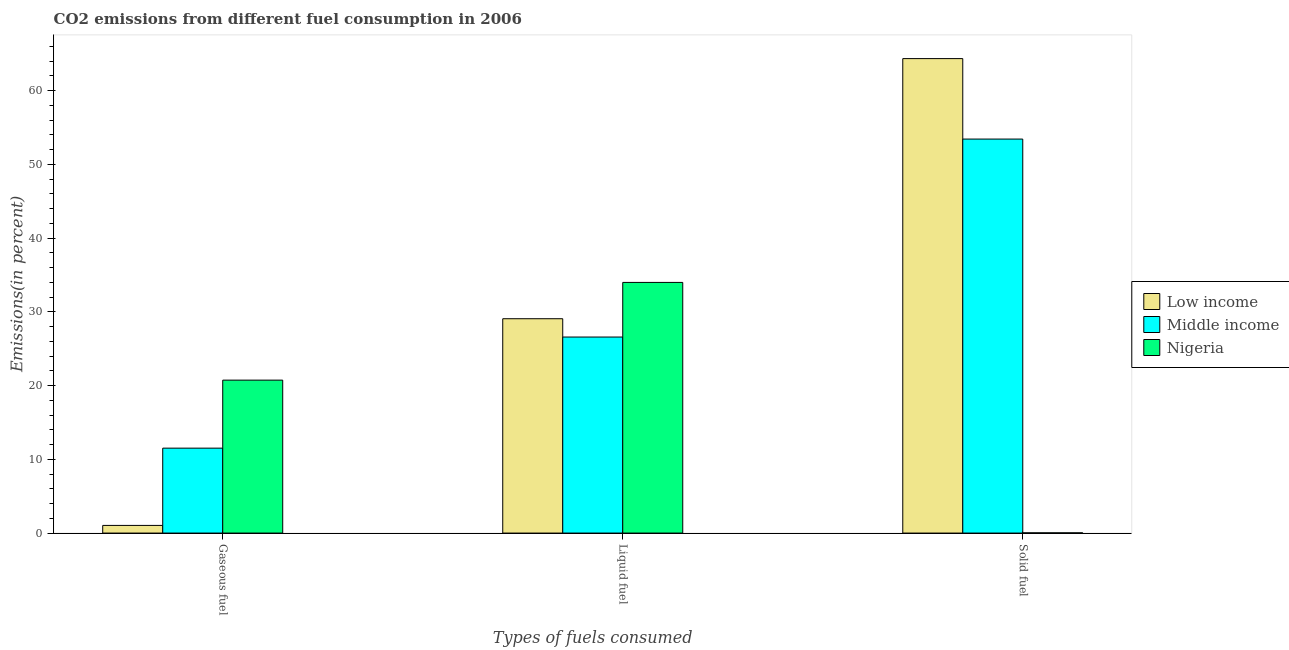How many different coloured bars are there?
Keep it short and to the point. 3. What is the label of the 3rd group of bars from the left?
Offer a terse response. Solid fuel. What is the percentage of solid fuel emission in Middle income?
Keep it short and to the point. 53.42. Across all countries, what is the maximum percentage of gaseous fuel emission?
Your answer should be compact. 20.74. Across all countries, what is the minimum percentage of solid fuel emission?
Keep it short and to the point. 0.03. In which country was the percentage of gaseous fuel emission maximum?
Your answer should be compact. Nigeria. In which country was the percentage of solid fuel emission minimum?
Ensure brevity in your answer.  Nigeria. What is the total percentage of gaseous fuel emission in the graph?
Provide a succinct answer. 33.29. What is the difference between the percentage of gaseous fuel emission in Middle income and that in Nigeria?
Keep it short and to the point. -9.22. What is the difference between the percentage of liquid fuel emission in Low income and the percentage of gaseous fuel emission in Nigeria?
Your answer should be compact. 8.33. What is the average percentage of gaseous fuel emission per country?
Your answer should be compact. 11.1. What is the difference between the percentage of liquid fuel emission and percentage of gaseous fuel emission in Middle income?
Keep it short and to the point. 15.06. What is the ratio of the percentage of solid fuel emission in Middle income to that in Low income?
Offer a very short reply. 0.83. What is the difference between the highest and the second highest percentage of liquid fuel emission?
Make the answer very short. 4.92. What is the difference between the highest and the lowest percentage of gaseous fuel emission?
Provide a short and direct response. 19.7. What does the 3rd bar from the left in Solid fuel represents?
Your answer should be very brief. Nigeria. What does the 1st bar from the right in Liquid fuel represents?
Give a very brief answer. Nigeria. Is it the case that in every country, the sum of the percentage of gaseous fuel emission and percentage of liquid fuel emission is greater than the percentage of solid fuel emission?
Make the answer very short. No. How many bars are there?
Give a very brief answer. 9. Are all the bars in the graph horizontal?
Your answer should be very brief. No. Are the values on the major ticks of Y-axis written in scientific E-notation?
Offer a very short reply. No. Does the graph contain grids?
Provide a short and direct response. No. How many legend labels are there?
Ensure brevity in your answer.  3. How are the legend labels stacked?
Keep it short and to the point. Vertical. What is the title of the graph?
Offer a very short reply. CO2 emissions from different fuel consumption in 2006. What is the label or title of the X-axis?
Keep it short and to the point. Types of fuels consumed. What is the label or title of the Y-axis?
Make the answer very short. Emissions(in percent). What is the Emissions(in percent) of Low income in Gaseous fuel?
Keep it short and to the point. 1.04. What is the Emissions(in percent) in Middle income in Gaseous fuel?
Your response must be concise. 11.52. What is the Emissions(in percent) in Nigeria in Gaseous fuel?
Ensure brevity in your answer.  20.74. What is the Emissions(in percent) of Low income in Liquid fuel?
Your answer should be compact. 29.06. What is the Emissions(in percent) of Middle income in Liquid fuel?
Your answer should be very brief. 26.58. What is the Emissions(in percent) of Nigeria in Liquid fuel?
Ensure brevity in your answer.  33.98. What is the Emissions(in percent) of Low income in Solid fuel?
Provide a succinct answer. 64.33. What is the Emissions(in percent) in Middle income in Solid fuel?
Make the answer very short. 53.42. What is the Emissions(in percent) of Nigeria in Solid fuel?
Offer a terse response. 0.03. Across all Types of fuels consumed, what is the maximum Emissions(in percent) of Low income?
Give a very brief answer. 64.33. Across all Types of fuels consumed, what is the maximum Emissions(in percent) in Middle income?
Your answer should be compact. 53.42. Across all Types of fuels consumed, what is the maximum Emissions(in percent) of Nigeria?
Your answer should be compact. 33.98. Across all Types of fuels consumed, what is the minimum Emissions(in percent) in Low income?
Your response must be concise. 1.04. Across all Types of fuels consumed, what is the minimum Emissions(in percent) in Middle income?
Keep it short and to the point. 11.52. Across all Types of fuels consumed, what is the minimum Emissions(in percent) in Nigeria?
Give a very brief answer. 0.03. What is the total Emissions(in percent) in Low income in the graph?
Offer a very short reply. 94.43. What is the total Emissions(in percent) in Middle income in the graph?
Give a very brief answer. 91.51. What is the total Emissions(in percent) in Nigeria in the graph?
Provide a succinct answer. 54.75. What is the difference between the Emissions(in percent) of Low income in Gaseous fuel and that in Liquid fuel?
Offer a terse response. -28.02. What is the difference between the Emissions(in percent) of Middle income in Gaseous fuel and that in Liquid fuel?
Make the answer very short. -15.06. What is the difference between the Emissions(in percent) in Nigeria in Gaseous fuel and that in Liquid fuel?
Ensure brevity in your answer.  -13.25. What is the difference between the Emissions(in percent) in Low income in Gaseous fuel and that in Solid fuel?
Your answer should be very brief. -63.29. What is the difference between the Emissions(in percent) of Middle income in Gaseous fuel and that in Solid fuel?
Your answer should be very brief. -41.9. What is the difference between the Emissions(in percent) of Nigeria in Gaseous fuel and that in Solid fuel?
Your answer should be compact. 20.71. What is the difference between the Emissions(in percent) in Low income in Liquid fuel and that in Solid fuel?
Your answer should be very brief. -35.27. What is the difference between the Emissions(in percent) of Middle income in Liquid fuel and that in Solid fuel?
Offer a very short reply. -26.84. What is the difference between the Emissions(in percent) of Nigeria in Liquid fuel and that in Solid fuel?
Provide a succinct answer. 33.95. What is the difference between the Emissions(in percent) in Low income in Gaseous fuel and the Emissions(in percent) in Middle income in Liquid fuel?
Ensure brevity in your answer.  -25.54. What is the difference between the Emissions(in percent) in Low income in Gaseous fuel and the Emissions(in percent) in Nigeria in Liquid fuel?
Give a very brief answer. -32.95. What is the difference between the Emissions(in percent) of Middle income in Gaseous fuel and the Emissions(in percent) of Nigeria in Liquid fuel?
Provide a succinct answer. -22.47. What is the difference between the Emissions(in percent) of Low income in Gaseous fuel and the Emissions(in percent) of Middle income in Solid fuel?
Ensure brevity in your answer.  -52.38. What is the difference between the Emissions(in percent) in Low income in Gaseous fuel and the Emissions(in percent) in Nigeria in Solid fuel?
Your answer should be very brief. 1.01. What is the difference between the Emissions(in percent) in Middle income in Gaseous fuel and the Emissions(in percent) in Nigeria in Solid fuel?
Give a very brief answer. 11.49. What is the difference between the Emissions(in percent) in Low income in Liquid fuel and the Emissions(in percent) in Middle income in Solid fuel?
Provide a succinct answer. -24.36. What is the difference between the Emissions(in percent) in Low income in Liquid fuel and the Emissions(in percent) in Nigeria in Solid fuel?
Offer a very short reply. 29.03. What is the difference between the Emissions(in percent) of Middle income in Liquid fuel and the Emissions(in percent) of Nigeria in Solid fuel?
Your response must be concise. 26.55. What is the average Emissions(in percent) in Low income per Types of fuels consumed?
Keep it short and to the point. 31.48. What is the average Emissions(in percent) in Middle income per Types of fuels consumed?
Make the answer very short. 30.5. What is the average Emissions(in percent) of Nigeria per Types of fuels consumed?
Make the answer very short. 18.25. What is the difference between the Emissions(in percent) of Low income and Emissions(in percent) of Middle income in Gaseous fuel?
Your answer should be very brief. -10.48. What is the difference between the Emissions(in percent) of Low income and Emissions(in percent) of Nigeria in Gaseous fuel?
Provide a succinct answer. -19.7. What is the difference between the Emissions(in percent) of Middle income and Emissions(in percent) of Nigeria in Gaseous fuel?
Ensure brevity in your answer.  -9.22. What is the difference between the Emissions(in percent) in Low income and Emissions(in percent) in Middle income in Liquid fuel?
Ensure brevity in your answer.  2.48. What is the difference between the Emissions(in percent) of Low income and Emissions(in percent) of Nigeria in Liquid fuel?
Make the answer very short. -4.92. What is the difference between the Emissions(in percent) of Middle income and Emissions(in percent) of Nigeria in Liquid fuel?
Your answer should be very brief. -7.41. What is the difference between the Emissions(in percent) of Low income and Emissions(in percent) of Middle income in Solid fuel?
Provide a succinct answer. 10.91. What is the difference between the Emissions(in percent) of Low income and Emissions(in percent) of Nigeria in Solid fuel?
Your answer should be very brief. 64.3. What is the difference between the Emissions(in percent) in Middle income and Emissions(in percent) in Nigeria in Solid fuel?
Keep it short and to the point. 53.39. What is the ratio of the Emissions(in percent) of Low income in Gaseous fuel to that in Liquid fuel?
Make the answer very short. 0.04. What is the ratio of the Emissions(in percent) in Middle income in Gaseous fuel to that in Liquid fuel?
Give a very brief answer. 0.43. What is the ratio of the Emissions(in percent) in Nigeria in Gaseous fuel to that in Liquid fuel?
Make the answer very short. 0.61. What is the ratio of the Emissions(in percent) of Low income in Gaseous fuel to that in Solid fuel?
Offer a terse response. 0.02. What is the ratio of the Emissions(in percent) of Middle income in Gaseous fuel to that in Solid fuel?
Offer a terse response. 0.22. What is the ratio of the Emissions(in percent) in Nigeria in Gaseous fuel to that in Solid fuel?
Ensure brevity in your answer.  696.38. What is the ratio of the Emissions(in percent) in Low income in Liquid fuel to that in Solid fuel?
Give a very brief answer. 0.45. What is the ratio of the Emissions(in percent) in Middle income in Liquid fuel to that in Solid fuel?
Your response must be concise. 0.5. What is the ratio of the Emissions(in percent) in Nigeria in Liquid fuel to that in Solid fuel?
Give a very brief answer. 1141.25. What is the difference between the highest and the second highest Emissions(in percent) of Low income?
Your answer should be very brief. 35.27. What is the difference between the highest and the second highest Emissions(in percent) of Middle income?
Offer a very short reply. 26.84. What is the difference between the highest and the second highest Emissions(in percent) of Nigeria?
Offer a very short reply. 13.25. What is the difference between the highest and the lowest Emissions(in percent) of Low income?
Offer a terse response. 63.29. What is the difference between the highest and the lowest Emissions(in percent) in Middle income?
Keep it short and to the point. 41.9. What is the difference between the highest and the lowest Emissions(in percent) of Nigeria?
Your answer should be very brief. 33.95. 